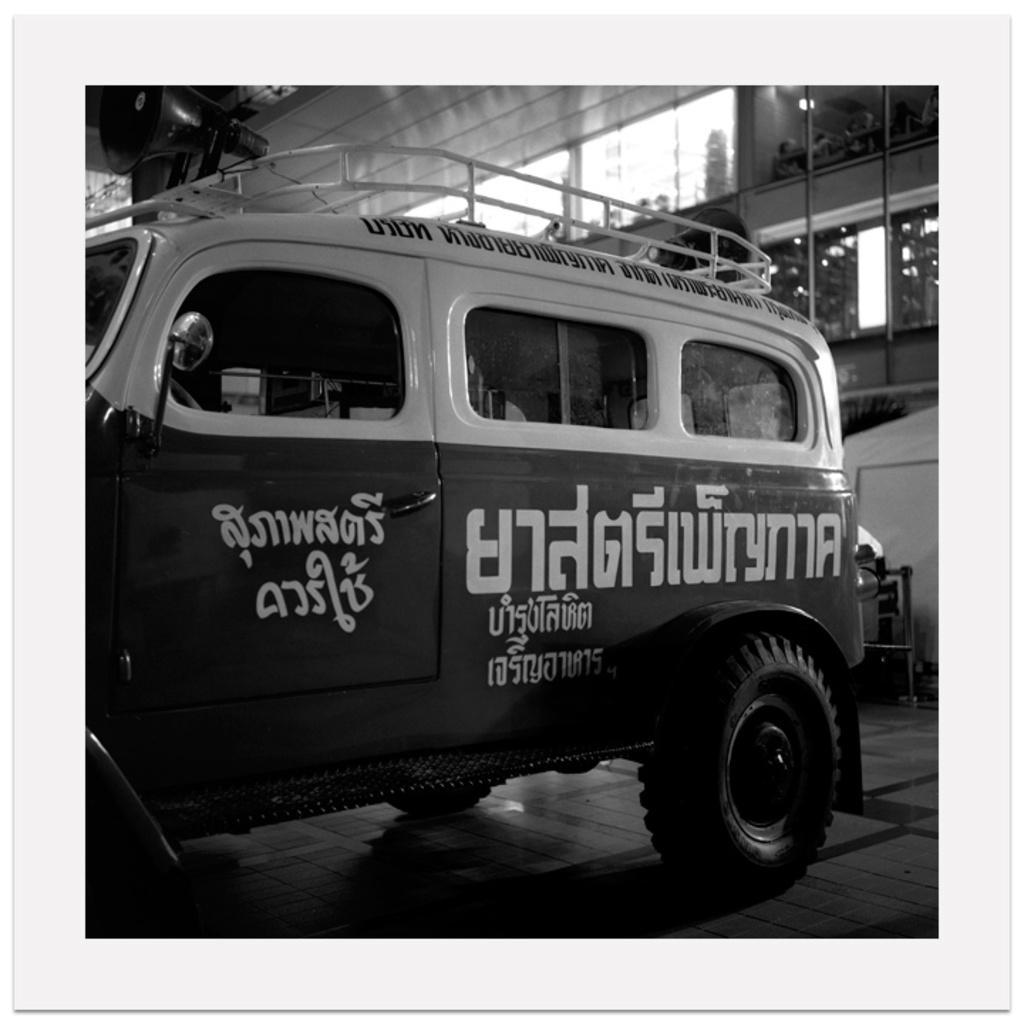Can you describe this image briefly? In this black and white picture there is a vehicle on the floor. Right side there are few objects on the floor. Background there is a wall. There is some text painted on the vehicle. 